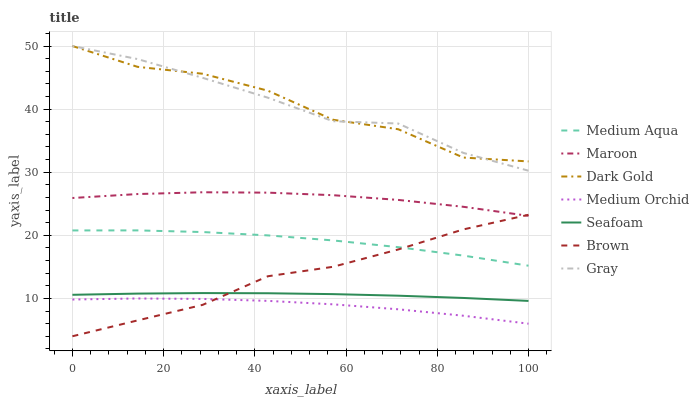Does Dark Gold have the minimum area under the curve?
Answer yes or no. No. Does Dark Gold have the maximum area under the curve?
Answer yes or no. No. Is Medium Orchid the smoothest?
Answer yes or no. No. Is Medium Orchid the roughest?
Answer yes or no. No. Does Medium Orchid have the lowest value?
Answer yes or no. No. Does Medium Orchid have the highest value?
Answer yes or no. No. Is Brown less than Dark Gold?
Answer yes or no. Yes. Is Maroon greater than Medium Aqua?
Answer yes or no. Yes. Does Brown intersect Dark Gold?
Answer yes or no. No. 